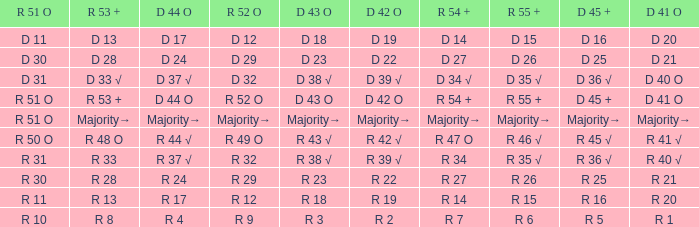Can you parse all the data within this table? {'header': ['R 51 O', 'R 53 +', 'D 44 O', 'R 52 O', 'D 43 O', 'D 42 O', 'R 54 +', 'R 55 +', 'D 45 +', 'D 41 O'], 'rows': [['D 11', 'D 13', 'D 17', 'D 12', 'D 18', 'D 19', 'D 14', 'D 15', 'D 16', 'D 20'], ['D 30', 'D 28', 'D 24', 'D 29', 'D 23', 'D 22', 'D 27', 'D 26', 'D 25', 'D 21'], ['D 31', 'D 33 √', 'D 37 √', 'D 32', 'D 38 √', 'D 39 √', 'D 34 √', 'D 35 √', 'D 36 √', 'D 40 O'], ['R 51 O', 'R 53 +', 'D 44 O', 'R 52 O', 'D 43 O', 'D 42 O', 'R 54 +', 'R 55 +', 'D 45 +', 'D 41 O'], ['R 51 O', 'Majority→', 'Majority→', 'Majority→', 'Majority→', 'Majority→', 'Majority→', 'Majority→', 'Majority→', 'Majority→'], ['R 50 O', 'R 48 O', 'R 44 √', 'R 49 O', 'R 43 √', 'R 42 √', 'R 47 O', 'R 46 √', 'R 45 √', 'R 41 √'], ['R 31', 'R 33', 'R 37 √', 'R 32', 'R 38 √', 'R 39 √', 'R 34', 'R 35 √', 'R 36 √', 'R 40 √'], ['R 30', 'R 28', 'R 24', 'R 29', 'R 23', 'R 22', 'R 27', 'R 26', 'R 25', 'R 21'], ['R 11', 'R 13', 'R 17', 'R 12', 'R 18', 'R 19', 'R 14', 'R 15', 'R 16', 'R 20'], ['R 10', 'R 8', 'R 4', 'R 9', 'R 3', 'R 2', 'R 7', 'R 6', 'R 5', 'R 1']]} What is the value of D 43 O that has a corresponding R 53 + value of r 8? R 3. 